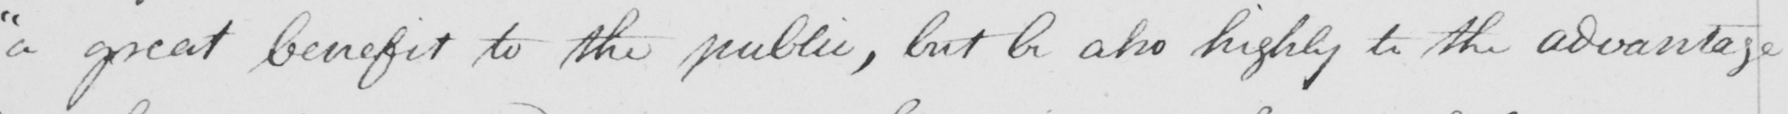Please provide the text content of this handwritten line. "a great benefit to the public, but be also highly to the advantage 